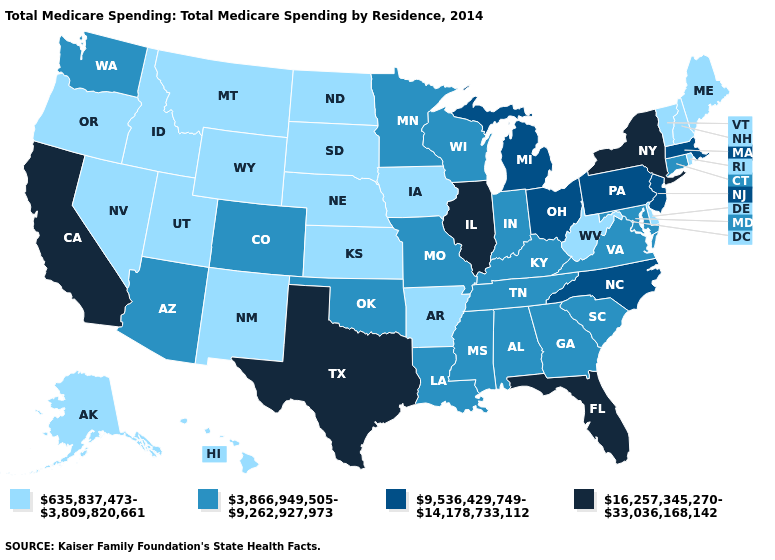Among the states that border New Hampshire , which have the highest value?
Be succinct. Massachusetts. What is the value of Massachusetts?
Answer briefly. 9,536,429,749-14,178,733,112. What is the highest value in the South ?
Quick response, please. 16,257,345,270-33,036,168,142. Which states have the highest value in the USA?
Be succinct. California, Florida, Illinois, New York, Texas. What is the lowest value in the West?
Short answer required. 635,837,473-3,809,820,661. Does Montana have the highest value in the West?
Answer briefly. No. Name the states that have a value in the range 16,257,345,270-33,036,168,142?
Concise answer only. California, Florida, Illinois, New York, Texas. Which states have the highest value in the USA?
Quick response, please. California, Florida, Illinois, New York, Texas. Which states have the highest value in the USA?
Short answer required. California, Florida, Illinois, New York, Texas. Name the states that have a value in the range 9,536,429,749-14,178,733,112?
Be succinct. Massachusetts, Michigan, New Jersey, North Carolina, Ohio, Pennsylvania. Which states hav the highest value in the Northeast?
Concise answer only. New York. Does Pennsylvania have a lower value than Maine?
Quick response, please. No. Name the states that have a value in the range 635,837,473-3,809,820,661?
Quick response, please. Alaska, Arkansas, Delaware, Hawaii, Idaho, Iowa, Kansas, Maine, Montana, Nebraska, Nevada, New Hampshire, New Mexico, North Dakota, Oregon, Rhode Island, South Dakota, Utah, Vermont, West Virginia, Wyoming. Among the states that border Tennessee , does Arkansas have the lowest value?
Write a very short answer. Yes. What is the highest value in states that border Illinois?
Give a very brief answer. 3,866,949,505-9,262,927,973. 